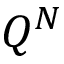<formula> <loc_0><loc_0><loc_500><loc_500>Q ^ { N }</formula> 